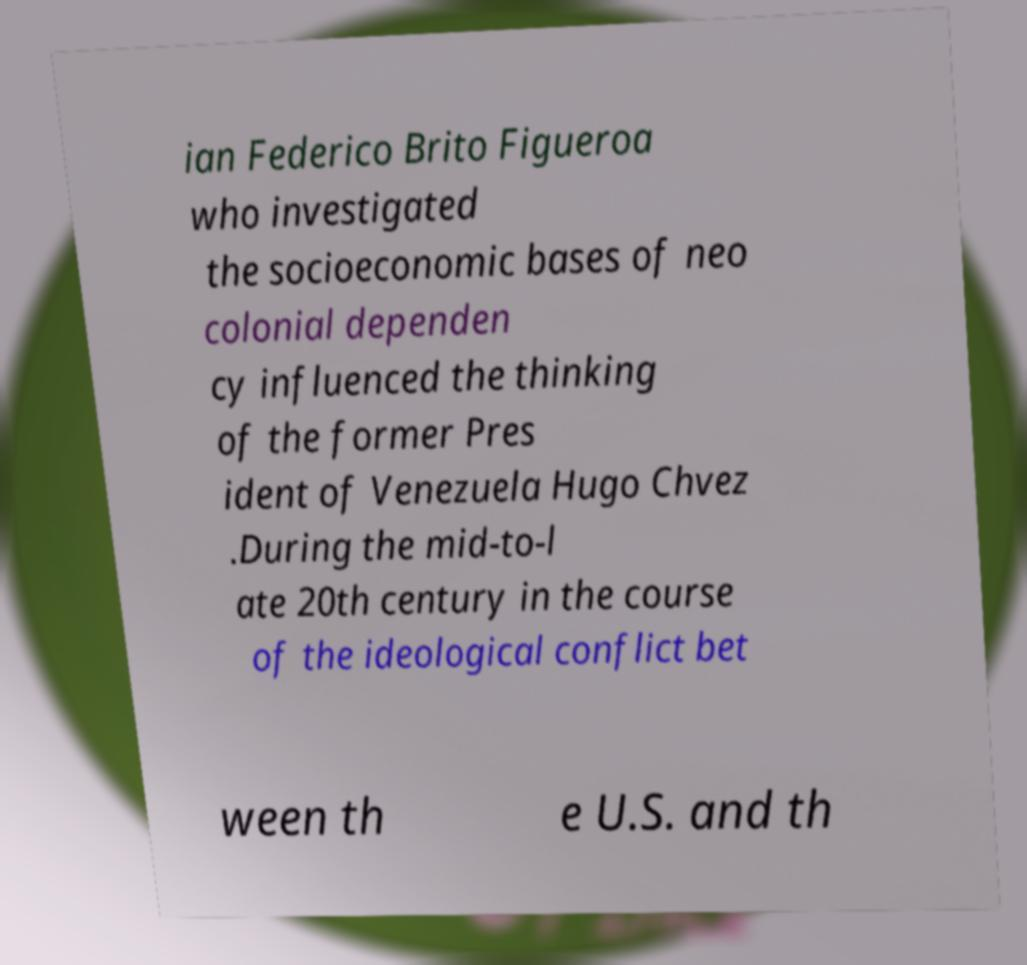Could you assist in decoding the text presented in this image and type it out clearly? ian Federico Brito Figueroa who investigated the socioeconomic bases of neo colonial dependen cy influenced the thinking of the former Pres ident of Venezuela Hugo Chvez .During the mid-to-l ate 20th century in the course of the ideological conflict bet ween th e U.S. and th 